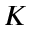Convert formula to latex. <formula><loc_0><loc_0><loc_500><loc_500>K</formula> 